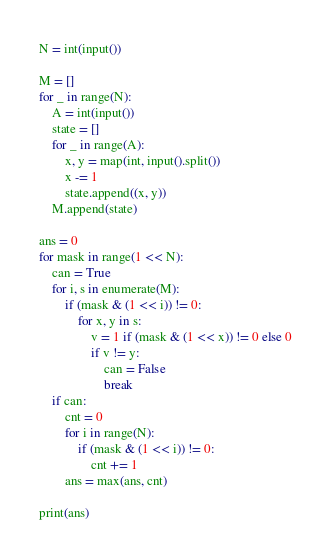Convert code to text. <code><loc_0><loc_0><loc_500><loc_500><_Python_>N = int(input())

M = []
for _ in range(N):
    A = int(input())
    state = []
    for _ in range(A):
        x, y = map(int, input().split())
        x -= 1
        state.append((x, y))
    M.append(state)

ans = 0
for mask in range(1 << N):
    can = True
    for i, s in enumerate(M):
        if (mask & (1 << i)) != 0:
            for x, y in s:
                v = 1 if (mask & (1 << x)) != 0 else 0
                if v != y:
                    can = False
                    break
    if can:
        cnt = 0
        for i in range(N):
            if (mask & (1 << i)) != 0:
                cnt += 1
        ans = max(ans, cnt)

print(ans)</code> 